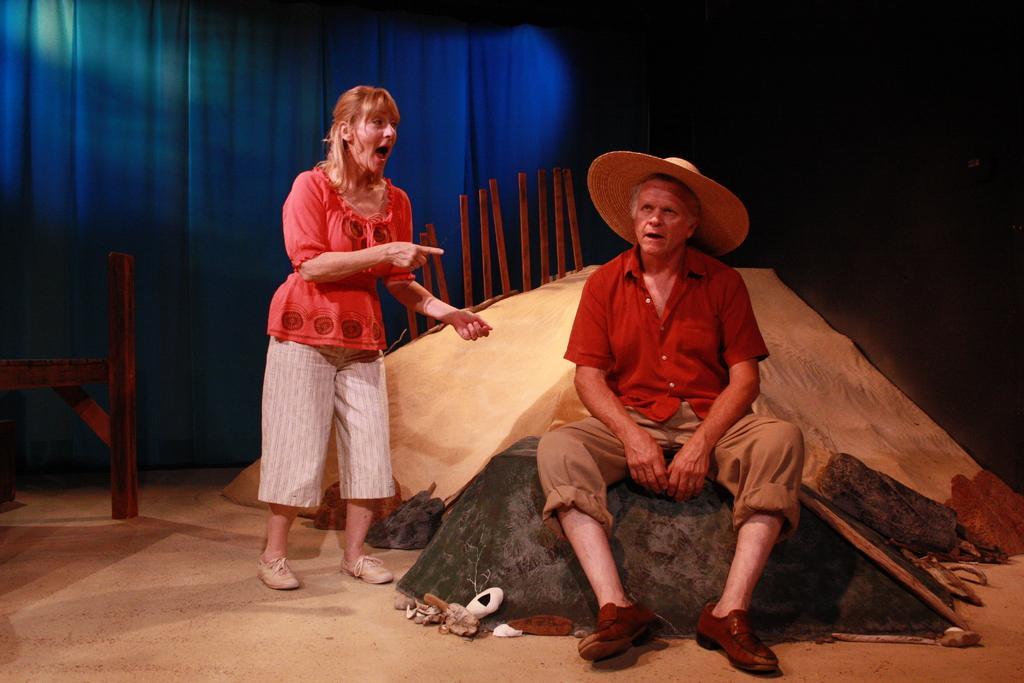In one or two sentences, can you explain what this image depicts? In this image I can see a person sitting on the rock and one person is standing. They are wearing different dresses. Back I can see the cream color cloth,few sticks and few objects on the floor. Back I can see a blue and black color background. 